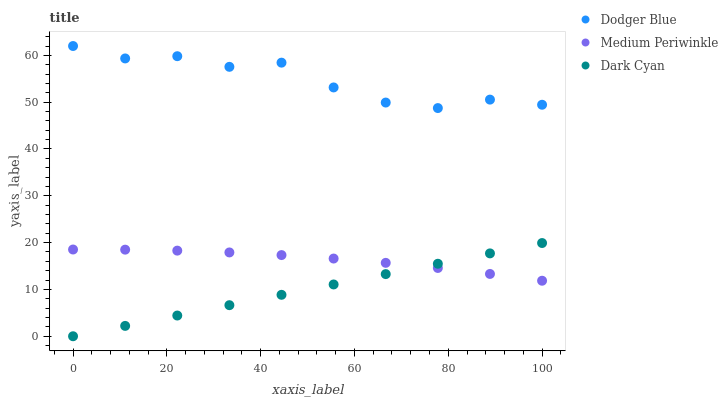Does Dark Cyan have the minimum area under the curve?
Answer yes or no. Yes. Does Dodger Blue have the maximum area under the curve?
Answer yes or no. Yes. Does Medium Periwinkle have the minimum area under the curve?
Answer yes or no. No. Does Medium Periwinkle have the maximum area under the curve?
Answer yes or no. No. Is Dark Cyan the smoothest?
Answer yes or no. Yes. Is Dodger Blue the roughest?
Answer yes or no. Yes. Is Medium Periwinkle the smoothest?
Answer yes or no. No. Is Medium Periwinkle the roughest?
Answer yes or no. No. Does Dark Cyan have the lowest value?
Answer yes or no. Yes. Does Medium Periwinkle have the lowest value?
Answer yes or no. No. Does Dodger Blue have the highest value?
Answer yes or no. Yes. Does Medium Periwinkle have the highest value?
Answer yes or no. No. Is Medium Periwinkle less than Dodger Blue?
Answer yes or no. Yes. Is Dodger Blue greater than Dark Cyan?
Answer yes or no. Yes. Does Dark Cyan intersect Medium Periwinkle?
Answer yes or no. Yes. Is Dark Cyan less than Medium Periwinkle?
Answer yes or no. No. Is Dark Cyan greater than Medium Periwinkle?
Answer yes or no. No. Does Medium Periwinkle intersect Dodger Blue?
Answer yes or no. No. 